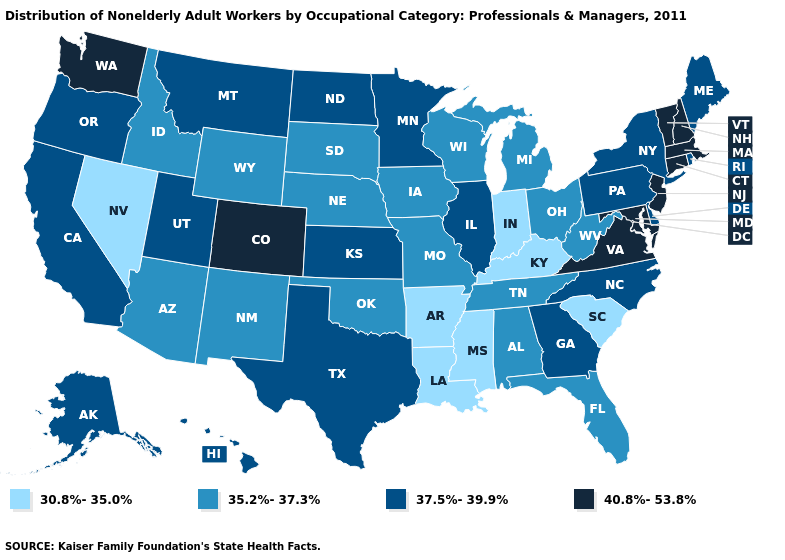How many symbols are there in the legend?
Write a very short answer. 4. Does Washington have the lowest value in the West?
Short answer required. No. What is the value of Connecticut?
Keep it brief. 40.8%-53.8%. Among the states that border West Virginia , which have the highest value?
Keep it brief. Maryland, Virginia. Name the states that have a value in the range 30.8%-35.0%?
Concise answer only. Arkansas, Indiana, Kentucky, Louisiana, Mississippi, Nevada, South Carolina. What is the lowest value in the USA?
Give a very brief answer. 30.8%-35.0%. Which states have the lowest value in the USA?
Concise answer only. Arkansas, Indiana, Kentucky, Louisiana, Mississippi, Nevada, South Carolina. Among the states that border Maryland , which have the lowest value?
Quick response, please. West Virginia. What is the lowest value in states that border Alabama?
Answer briefly. 30.8%-35.0%. What is the highest value in the USA?
Answer briefly. 40.8%-53.8%. How many symbols are there in the legend?
Write a very short answer. 4. Which states hav the highest value in the South?
Write a very short answer. Maryland, Virginia. Does Indiana have the lowest value in the MidWest?
Give a very brief answer. Yes. Name the states that have a value in the range 40.8%-53.8%?
Concise answer only. Colorado, Connecticut, Maryland, Massachusetts, New Hampshire, New Jersey, Vermont, Virginia, Washington. Name the states that have a value in the range 35.2%-37.3%?
Give a very brief answer. Alabama, Arizona, Florida, Idaho, Iowa, Michigan, Missouri, Nebraska, New Mexico, Ohio, Oklahoma, South Dakota, Tennessee, West Virginia, Wisconsin, Wyoming. 